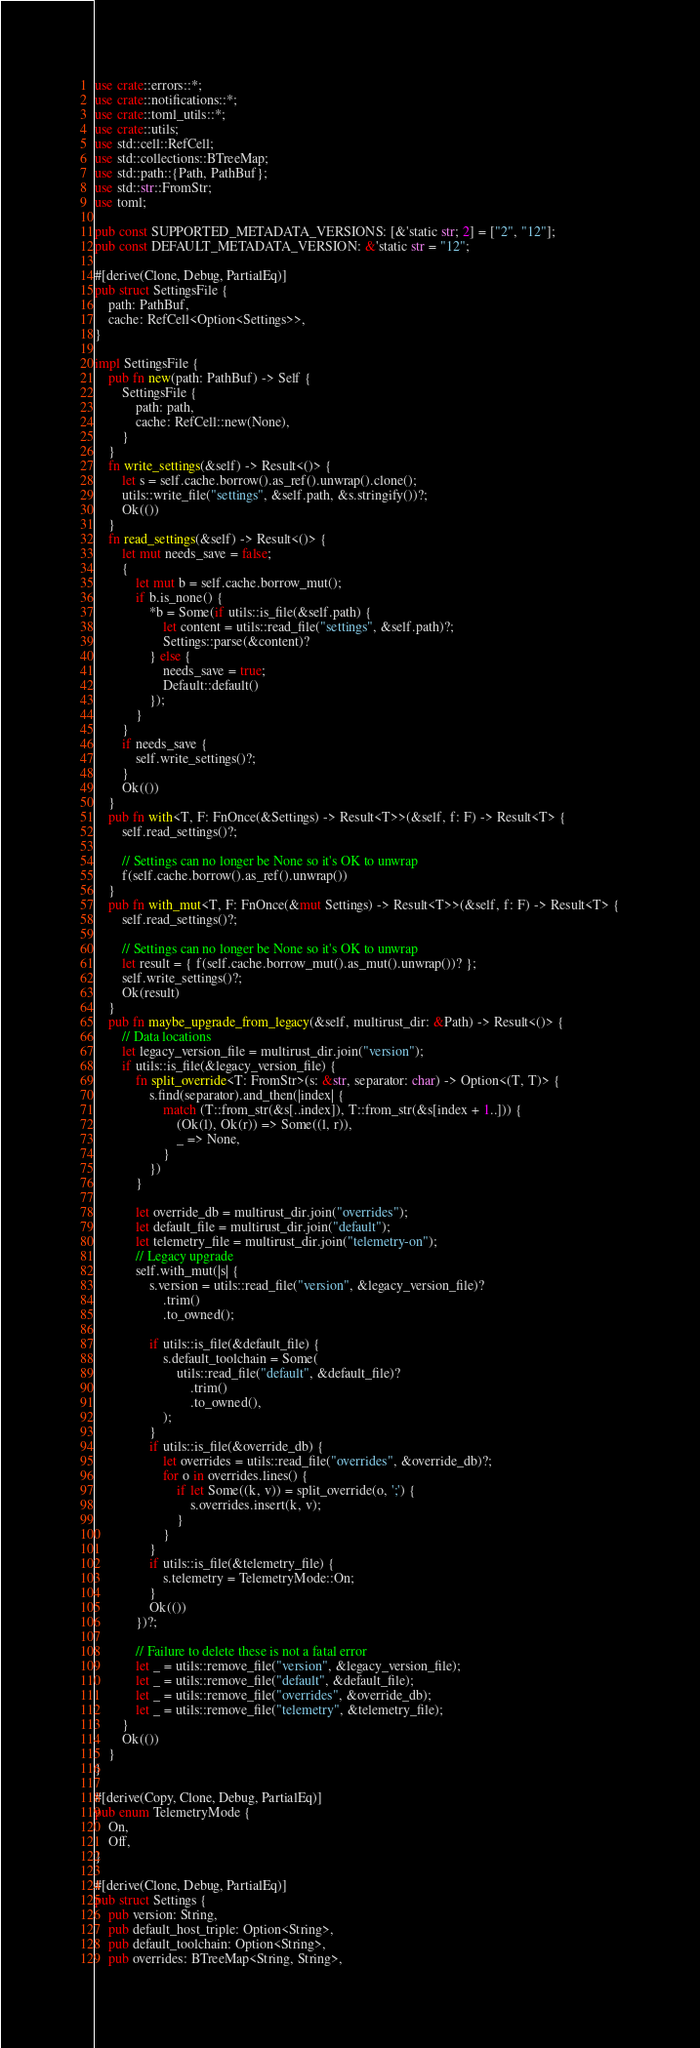<code> <loc_0><loc_0><loc_500><loc_500><_Rust_>use crate::errors::*;
use crate::notifications::*;
use crate::toml_utils::*;
use crate::utils;
use std::cell::RefCell;
use std::collections::BTreeMap;
use std::path::{Path, PathBuf};
use std::str::FromStr;
use toml;

pub const SUPPORTED_METADATA_VERSIONS: [&'static str; 2] = ["2", "12"];
pub const DEFAULT_METADATA_VERSION: &'static str = "12";

#[derive(Clone, Debug, PartialEq)]
pub struct SettingsFile {
    path: PathBuf,
    cache: RefCell<Option<Settings>>,
}

impl SettingsFile {
    pub fn new(path: PathBuf) -> Self {
        SettingsFile {
            path: path,
            cache: RefCell::new(None),
        }
    }
    fn write_settings(&self) -> Result<()> {
        let s = self.cache.borrow().as_ref().unwrap().clone();
        utils::write_file("settings", &self.path, &s.stringify())?;
        Ok(())
    }
    fn read_settings(&self) -> Result<()> {
        let mut needs_save = false;
        {
            let mut b = self.cache.borrow_mut();
            if b.is_none() {
                *b = Some(if utils::is_file(&self.path) {
                    let content = utils::read_file("settings", &self.path)?;
                    Settings::parse(&content)?
                } else {
                    needs_save = true;
                    Default::default()
                });
            }
        }
        if needs_save {
            self.write_settings()?;
        }
        Ok(())
    }
    pub fn with<T, F: FnOnce(&Settings) -> Result<T>>(&self, f: F) -> Result<T> {
        self.read_settings()?;

        // Settings can no longer be None so it's OK to unwrap
        f(self.cache.borrow().as_ref().unwrap())
    }
    pub fn with_mut<T, F: FnOnce(&mut Settings) -> Result<T>>(&self, f: F) -> Result<T> {
        self.read_settings()?;

        // Settings can no longer be None so it's OK to unwrap
        let result = { f(self.cache.borrow_mut().as_mut().unwrap())? };
        self.write_settings()?;
        Ok(result)
    }
    pub fn maybe_upgrade_from_legacy(&self, multirust_dir: &Path) -> Result<()> {
        // Data locations
        let legacy_version_file = multirust_dir.join("version");
        if utils::is_file(&legacy_version_file) {
            fn split_override<T: FromStr>(s: &str, separator: char) -> Option<(T, T)> {
                s.find(separator).and_then(|index| {
                    match (T::from_str(&s[..index]), T::from_str(&s[index + 1..])) {
                        (Ok(l), Ok(r)) => Some((l, r)),
                        _ => None,
                    }
                })
            }

            let override_db = multirust_dir.join("overrides");
            let default_file = multirust_dir.join("default");
            let telemetry_file = multirust_dir.join("telemetry-on");
            // Legacy upgrade
            self.with_mut(|s| {
                s.version = utils::read_file("version", &legacy_version_file)?
                    .trim()
                    .to_owned();

                if utils::is_file(&default_file) {
                    s.default_toolchain = Some(
                        utils::read_file("default", &default_file)?
                            .trim()
                            .to_owned(),
                    );
                }
                if utils::is_file(&override_db) {
                    let overrides = utils::read_file("overrides", &override_db)?;
                    for o in overrides.lines() {
                        if let Some((k, v)) = split_override(o, ';') {
                            s.overrides.insert(k, v);
                        }
                    }
                }
                if utils::is_file(&telemetry_file) {
                    s.telemetry = TelemetryMode::On;
                }
                Ok(())
            })?;

            // Failure to delete these is not a fatal error
            let _ = utils::remove_file("version", &legacy_version_file);
            let _ = utils::remove_file("default", &default_file);
            let _ = utils::remove_file("overrides", &override_db);
            let _ = utils::remove_file("telemetry", &telemetry_file);
        }
        Ok(())
    }
}

#[derive(Copy, Clone, Debug, PartialEq)]
pub enum TelemetryMode {
    On,
    Off,
}

#[derive(Clone, Debug, PartialEq)]
pub struct Settings {
    pub version: String,
    pub default_host_triple: Option<String>,
    pub default_toolchain: Option<String>,
    pub overrides: BTreeMap<String, String>,</code> 